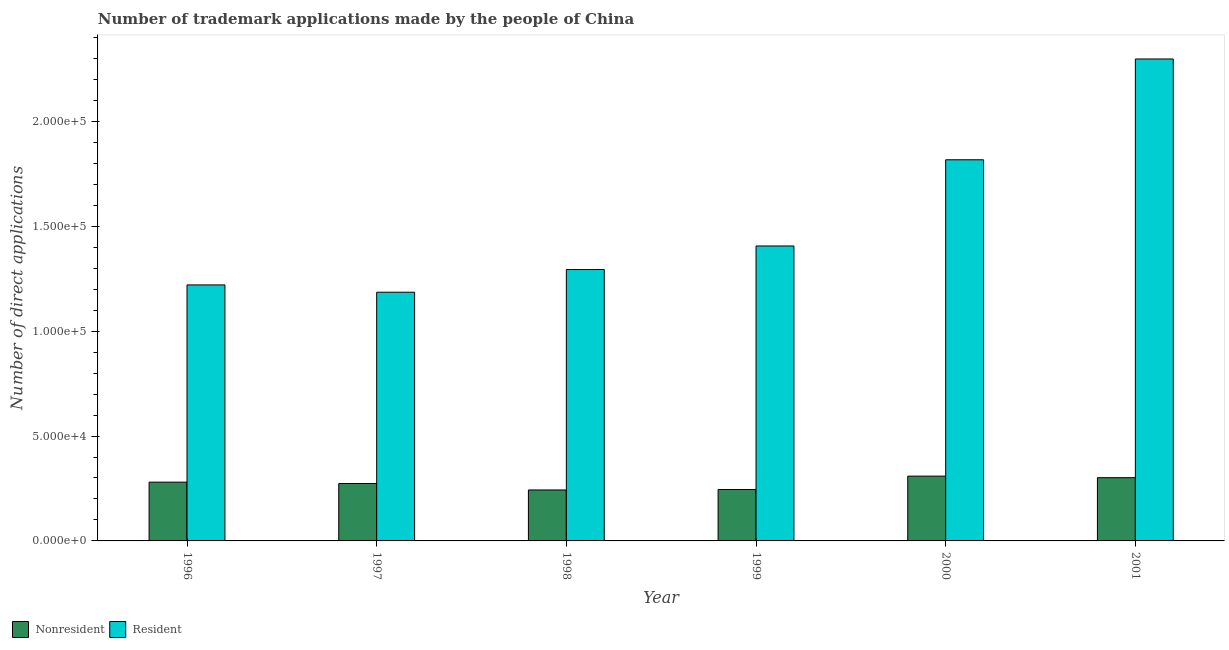How many groups of bars are there?
Ensure brevity in your answer.  6. Are the number of bars on each tick of the X-axis equal?
Give a very brief answer. Yes. How many bars are there on the 4th tick from the left?
Make the answer very short. 2. What is the label of the 3rd group of bars from the left?
Your response must be concise. 1998. What is the number of trademark applications made by residents in 2000?
Offer a very short reply. 1.82e+05. Across all years, what is the maximum number of trademark applications made by non residents?
Your answer should be very brief. 3.09e+04. Across all years, what is the minimum number of trademark applications made by non residents?
Provide a short and direct response. 2.43e+04. In which year was the number of trademark applications made by residents maximum?
Give a very brief answer. 2001. In which year was the number of trademark applications made by non residents minimum?
Give a very brief answer. 1998. What is the total number of trademark applications made by residents in the graph?
Keep it short and to the point. 9.22e+05. What is the difference between the number of trademark applications made by residents in 1996 and that in 1999?
Your response must be concise. -1.86e+04. What is the difference between the number of trademark applications made by residents in 1996 and the number of trademark applications made by non residents in 2001?
Offer a terse response. -1.08e+05. What is the average number of trademark applications made by residents per year?
Offer a terse response. 1.54e+05. In how many years, is the number of trademark applications made by residents greater than 210000?
Your answer should be very brief. 1. What is the ratio of the number of trademark applications made by residents in 1999 to that in 2001?
Give a very brief answer. 0.61. Is the number of trademark applications made by residents in 1996 less than that in 2000?
Keep it short and to the point. Yes. What is the difference between the highest and the second highest number of trademark applications made by non residents?
Keep it short and to the point. 736. What is the difference between the highest and the lowest number of trademark applications made by non residents?
Ensure brevity in your answer.  6587. In how many years, is the number of trademark applications made by residents greater than the average number of trademark applications made by residents taken over all years?
Your answer should be compact. 2. What does the 1st bar from the left in 1998 represents?
Offer a very short reply. Nonresident. What does the 1st bar from the right in 1998 represents?
Make the answer very short. Resident. Does the graph contain any zero values?
Keep it short and to the point. No. Does the graph contain grids?
Offer a very short reply. No. What is the title of the graph?
Your response must be concise. Number of trademark applications made by the people of China. What is the label or title of the Y-axis?
Offer a very short reply. Number of direct applications. What is the Number of direct applications in Nonresident in 1996?
Provide a short and direct response. 2.80e+04. What is the Number of direct applications in Resident in 1996?
Your answer should be compact. 1.22e+05. What is the Number of direct applications of Nonresident in 1997?
Your answer should be compact. 2.74e+04. What is the Number of direct applications of Resident in 1997?
Your answer should be compact. 1.19e+05. What is the Number of direct applications in Nonresident in 1998?
Make the answer very short. 2.43e+04. What is the Number of direct applications of Resident in 1998?
Provide a short and direct response. 1.29e+05. What is the Number of direct applications in Nonresident in 1999?
Offer a very short reply. 2.45e+04. What is the Number of direct applications of Resident in 1999?
Your answer should be compact. 1.41e+05. What is the Number of direct applications of Nonresident in 2000?
Your answer should be very brief. 3.09e+04. What is the Number of direct applications of Resident in 2000?
Offer a very short reply. 1.82e+05. What is the Number of direct applications of Nonresident in 2001?
Provide a succinct answer. 3.01e+04. What is the Number of direct applications of Resident in 2001?
Provide a short and direct response. 2.30e+05. Across all years, what is the maximum Number of direct applications of Nonresident?
Offer a very short reply. 3.09e+04. Across all years, what is the maximum Number of direct applications of Resident?
Make the answer very short. 2.30e+05. Across all years, what is the minimum Number of direct applications in Nonresident?
Keep it short and to the point. 2.43e+04. Across all years, what is the minimum Number of direct applications of Resident?
Your response must be concise. 1.19e+05. What is the total Number of direct applications of Nonresident in the graph?
Give a very brief answer. 1.65e+05. What is the total Number of direct applications of Resident in the graph?
Offer a very short reply. 9.22e+05. What is the difference between the Number of direct applications in Nonresident in 1996 and that in 1997?
Your answer should be compact. 650. What is the difference between the Number of direct applications of Resident in 1996 and that in 1997?
Ensure brevity in your answer.  3480. What is the difference between the Number of direct applications in Nonresident in 1996 and that in 1998?
Your response must be concise. 3719. What is the difference between the Number of direct applications in Resident in 1996 and that in 1998?
Give a very brief answer. -7337. What is the difference between the Number of direct applications of Nonresident in 1996 and that in 1999?
Offer a very short reply. 3509. What is the difference between the Number of direct applications of Resident in 1996 and that in 1999?
Provide a succinct answer. -1.86e+04. What is the difference between the Number of direct applications in Nonresident in 1996 and that in 2000?
Offer a terse response. -2868. What is the difference between the Number of direct applications in Resident in 1996 and that in 2000?
Give a very brief answer. -5.97e+04. What is the difference between the Number of direct applications in Nonresident in 1996 and that in 2001?
Offer a terse response. -2132. What is the difference between the Number of direct applications of Resident in 1996 and that in 2001?
Make the answer very short. -1.08e+05. What is the difference between the Number of direct applications of Nonresident in 1997 and that in 1998?
Your answer should be very brief. 3069. What is the difference between the Number of direct applications in Resident in 1997 and that in 1998?
Provide a short and direct response. -1.08e+04. What is the difference between the Number of direct applications in Nonresident in 1997 and that in 1999?
Provide a short and direct response. 2859. What is the difference between the Number of direct applications of Resident in 1997 and that in 1999?
Ensure brevity in your answer.  -2.20e+04. What is the difference between the Number of direct applications in Nonresident in 1997 and that in 2000?
Your answer should be very brief. -3518. What is the difference between the Number of direct applications of Resident in 1997 and that in 2000?
Give a very brief answer. -6.31e+04. What is the difference between the Number of direct applications of Nonresident in 1997 and that in 2001?
Your answer should be very brief. -2782. What is the difference between the Number of direct applications in Resident in 1997 and that in 2001?
Your answer should be compact. -1.11e+05. What is the difference between the Number of direct applications of Nonresident in 1998 and that in 1999?
Give a very brief answer. -210. What is the difference between the Number of direct applications of Resident in 1998 and that in 1999?
Provide a succinct answer. -1.12e+04. What is the difference between the Number of direct applications in Nonresident in 1998 and that in 2000?
Ensure brevity in your answer.  -6587. What is the difference between the Number of direct applications of Resident in 1998 and that in 2000?
Make the answer very short. -5.23e+04. What is the difference between the Number of direct applications in Nonresident in 1998 and that in 2001?
Your answer should be compact. -5851. What is the difference between the Number of direct applications in Resident in 1998 and that in 2001?
Your response must be concise. -1.00e+05. What is the difference between the Number of direct applications of Nonresident in 1999 and that in 2000?
Give a very brief answer. -6377. What is the difference between the Number of direct applications in Resident in 1999 and that in 2000?
Keep it short and to the point. -4.11e+04. What is the difference between the Number of direct applications in Nonresident in 1999 and that in 2001?
Ensure brevity in your answer.  -5641. What is the difference between the Number of direct applications in Resident in 1999 and that in 2001?
Give a very brief answer. -8.92e+04. What is the difference between the Number of direct applications in Nonresident in 2000 and that in 2001?
Offer a very short reply. 736. What is the difference between the Number of direct applications in Resident in 2000 and that in 2001?
Provide a short and direct response. -4.81e+04. What is the difference between the Number of direct applications of Nonresident in 1996 and the Number of direct applications of Resident in 1997?
Your answer should be very brief. -9.06e+04. What is the difference between the Number of direct applications in Nonresident in 1996 and the Number of direct applications in Resident in 1998?
Make the answer very short. -1.01e+05. What is the difference between the Number of direct applications of Nonresident in 1996 and the Number of direct applications of Resident in 1999?
Your answer should be very brief. -1.13e+05. What is the difference between the Number of direct applications in Nonresident in 1996 and the Number of direct applications in Resident in 2000?
Your response must be concise. -1.54e+05. What is the difference between the Number of direct applications in Nonresident in 1996 and the Number of direct applications in Resident in 2001?
Your answer should be very brief. -2.02e+05. What is the difference between the Number of direct applications in Nonresident in 1997 and the Number of direct applications in Resident in 1998?
Ensure brevity in your answer.  -1.02e+05. What is the difference between the Number of direct applications of Nonresident in 1997 and the Number of direct applications of Resident in 1999?
Ensure brevity in your answer.  -1.13e+05. What is the difference between the Number of direct applications in Nonresident in 1997 and the Number of direct applications in Resident in 2000?
Your answer should be very brief. -1.54e+05. What is the difference between the Number of direct applications of Nonresident in 1997 and the Number of direct applications of Resident in 2001?
Offer a very short reply. -2.02e+05. What is the difference between the Number of direct applications of Nonresident in 1998 and the Number of direct applications of Resident in 1999?
Ensure brevity in your answer.  -1.16e+05. What is the difference between the Number of direct applications in Nonresident in 1998 and the Number of direct applications in Resident in 2000?
Offer a very short reply. -1.57e+05. What is the difference between the Number of direct applications of Nonresident in 1998 and the Number of direct applications of Resident in 2001?
Provide a succinct answer. -2.05e+05. What is the difference between the Number of direct applications in Nonresident in 1999 and the Number of direct applications in Resident in 2000?
Your answer should be very brief. -1.57e+05. What is the difference between the Number of direct applications in Nonresident in 1999 and the Number of direct applications in Resident in 2001?
Give a very brief answer. -2.05e+05. What is the difference between the Number of direct applications in Nonresident in 2000 and the Number of direct applications in Resident in 2001?
Your answer should be very brief. -1.99e+05. What is the average Number of direct applications of Nonresident per year?
Provide a succinct answer. 2.75e+04. What is the average Number of direct applications of Resident per year?
Give a very brief answer. 1.54e+05. In the year 1996, what is the difference between the Number of direct applications in Nonresident and Number of direct applications in Resident?
Keep it short and to the point. -9.40e+04. In the year 1997, what is the difference between the Number of direct applications in Nonresident and Number of direct applications in Resident?
Provide a short and direct response. -9.12e+04. In the year 1998, what is the difference between the Number of direct applications of Nonresident and Number of direct applications of Resident?
Provide a succinct answer. -1.05e+05. In the year 1999, what is the difference between the Number of direct applications in Nonresident and Number of direct applications in Resident?
Keep it short and to the point. -1.16e+05. In the year 2000, what is the difference between the Number of direct applications in Nonresident and Number of direct applications in Resident?
Provide a succinct answer. -1.51e+05. In the year 2001, what is the difference between the Number of direct applications of Nonresident and Number of direct applications of Resident?
Give a very brief answer. -2.00e+05. What is the ratio of the Number of direct applications of Nonresident in 1996 to that in 1997?
Ensure brevity in your answer.  1.02. What is the ratio of the Number of direct applications in Resident in 1996 to that in 1997?
Give a very brief answer. 1.03. What is the ratio of the Number of direct applications in Nonresident in 1996 to that in 1998?
Your response must be concise. 1.15. What is the ratio of the Number of direct applications in Resident in 1996 to that in 1998?
Offer a terse response. 0.94. What is the ratio of the Number of direct applications of Nonresident in 1996 to that in 1999?
Give a very brief answer. 1.14. What is the ratio of the Number of direct applications of Resident in 1996 to that in 1999?
Give a very brief answer. 0.87. What is the ratio of the Number of direct applications in Nonresident in 1996 to that in 2000?
Make the answer very short. 0.91. What is the ratio of the Number of direct applications of Resident in 1996 to that in 2000?
Ensure brevity in your answer.  0.67. What is the ratio of the Number of direct applications of Nonresident in 1996 to that in 2001?
Offer a terse response. 0.93. What is the ratio of the Number of direct applications in Resident in 1996 to that in 2001?
Ensure brevity in your answer.  0.53. What is the ratio of the Number of direct applications of Nonresident in 1997 to that in 1998?
Keep it short and to the point. 1.13. What is the ratio of the Number of direct applications in Resident in 1997 to that in 1998?
Offer a terse response. 0.92. What is the ratio of the Number of direct applications of Nonresident in 1997 to that in 1999?
Offer a terse response. 1.12. What is the ratio of the Number of direct applications in Resident in 1997 to that in 1999?
Ensure brevity in your answer.  0.84. What is the ratio of the Number of direct applications of Nonresident in 1997 to that in 2000?
Make the answer very short. 0.89. What is the ratio of the Number of direct applications of Resident in 1997 to that in 2000?
Your answer should be very brief. 0.65. What is the ratio of the Number of direct applications of Nonresident in 1997 to that in 2001?
Ensure brevity in your answer.  0.91. What is the ratio of the Number of direct applications of Resident in 1997 to that in 2001?
Your response must be concise. 0.52. What is the ratio of the Number of direct applications of Resident in 1998 to that in 1999?
Provide a short and direct response. 0.92. What is the ratio of the Number of direct applications of Nonresident in 1998 to that in 2000?
Your answer should be compact. 0.79. What is the ratio of the Number of direct applications in Resident in 1998 to that in 2000?
Provide a succinct answer. 0.71. What is the ratio of the Number of direct applications in Nonresident in 1998 to that in 2001?
Make the answer very short. 0.81. What is the ratio of the Number of direct applications in Resident in 1998 to that in 2001?
Your response must be concise. 0.56. What is the ratio of the Number of direct applications in Nonresident in 1999 to that in 2000?
Offer a very short reply. 0.79. What is the ratio of the Number of direct applications of Resident in 1999 to that in 2000?
Make the answer very short. 0.77. What is the ratio of the Number of direct applications in Nonresident in 1999 to that in 2001?
Provide a short and direct response. 0.81. What is the ratio of the Number of direct applications of Resident in 1999 to that in 2001?
Offer a terse response. 0.61. What is the ratio of the Number of direct applications of Nonresident in 2000 to that in 2001?
Ensure brevity in your answer.  1.02. What is the ratio of the Number of direct applications of Resident in 2000 to that in 2001?
Provide a short and direct response. 0.79. What is the difference between the highest and the second highest Number of direct applications of Nonresident?
Make the answer very short. 736. What is the difference between the highest and the second highest Number of direct applications in Resident?
Ensure brevity in your answer.  4.81e+04. What is the difference between the highest and the lowest Number of direct applications of Nonresident?
Provide a succinct answer. 6587. What is the difference between the highest and the lowest Number of direct applications in Resident?
Provide a succinct answer. 1.11e+05. 